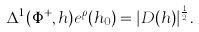<formula> <loc_0><loc_0><loc_500><loc_500>\Delta ^ { 1 } ( \Phi ^ { + } , h ) e ^ { \rho } ( h _ { 0 } ) = | D ( h ) | ^ { \frac { 1 } { 2 } } .</formula> 